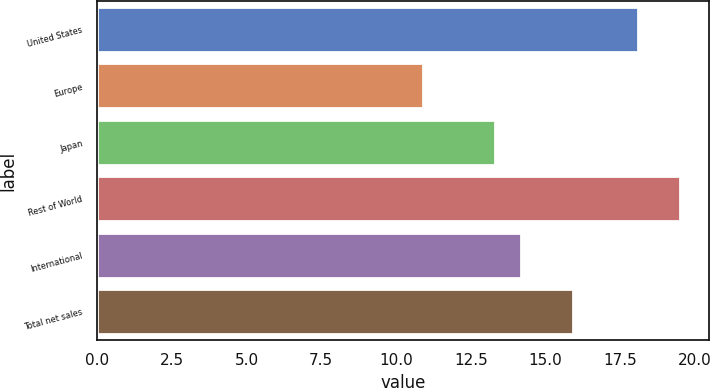Convert chart. <chart><loc_0><loc_0><loc_500><loc_500><bar_chart><fcel>United States<fcel>Europe<fcel>Japan<fcel>Rest of World<fcel>International<fcel>Total net sales<nl><fcel>18.1<fcel>10.9<fcel>13.3<fcel>19.5<fcel>14.16<fcel>15.9<nl></chart> 